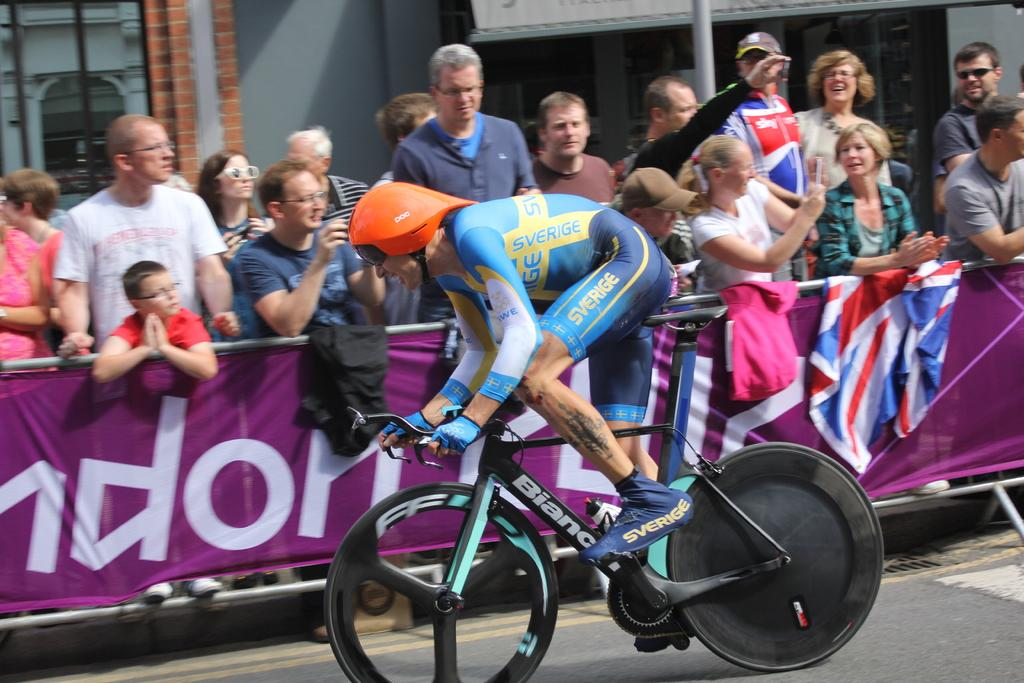What is the main subject of the image? There is a person riding a bicycle in the image. Where is the person riding the bicycle? The person is on a road. What can be seen in the background of the image? There is a banner, other persons, and a building in the background of the image. What color is the grape that the person riding the bicycle is holding in the image? There is no grape present in the image, and the person riding the bicycle is not holding any object. What is the size of the fan in the image? There is no fan present in the image. 